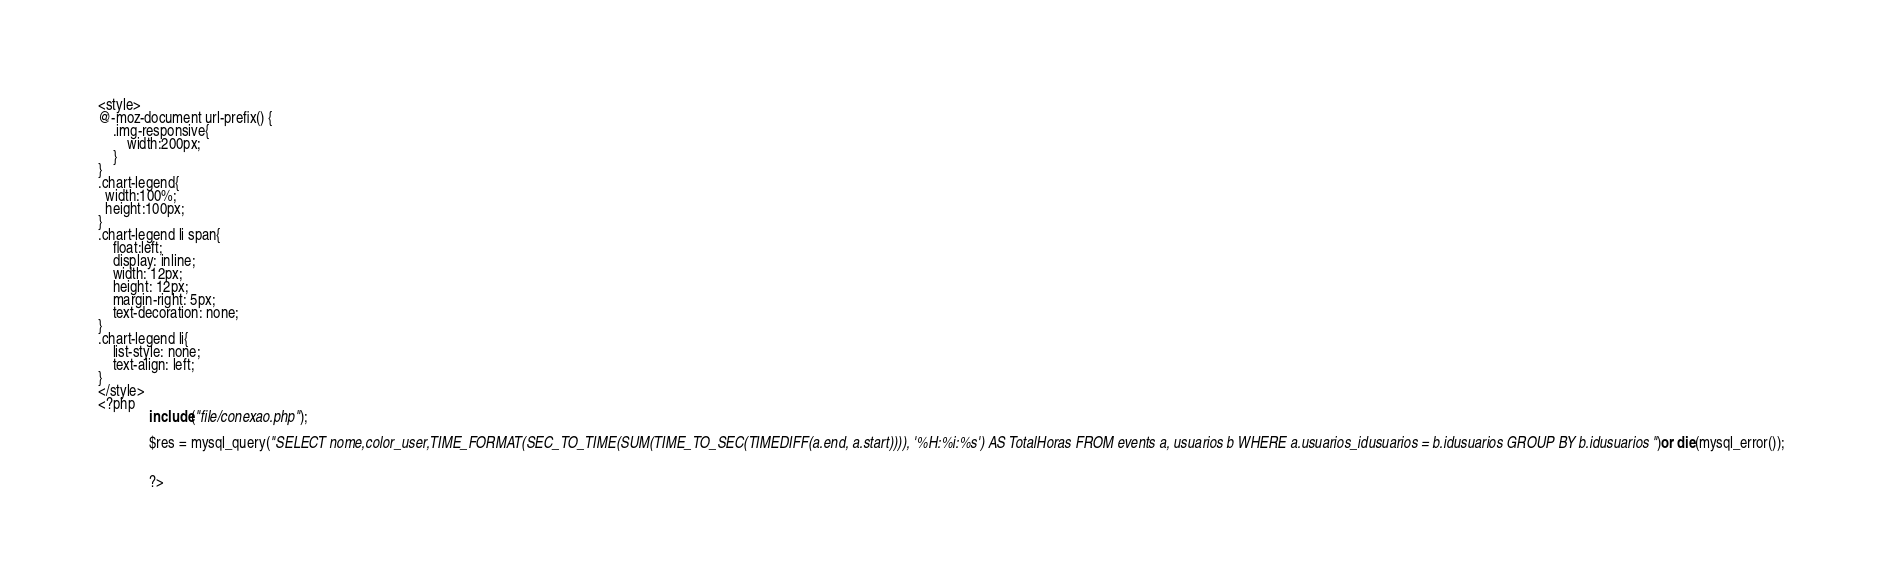Convert code to text. <code><loc_0><loc_0><loc_500><loc_500><_PHP_><style>
@-moz-document url-prefix() {
    .img-responsive{
        width:200px;
    }
}
.chart-legend{
  width:100%;
  height:100px;
}
.chart-legend li span{
    float:left;
    display: inline;
    width: 12px;
    height: 12px;
    margin-right: 5px;
    text-decoration: none;
}
.chart-legend li{
    list-style: none;
    text-align: left;
}
</style>
<?php
              include("file/conexao.php");

              $res = mysql_query("SELECT nome,color_user,TIME_FORMAT(SEC_TO_TIME(SUM(TIME_TO_SEC(TIMEDIFF(a.end, a.start)))), '%H:%i:%s') AS TotalHoras FROM events a, usuarios b WHERE a.usuarios_idusuarios = b.idusuarios GROUP BY b.idusuarios")or die(mysql_error());
              
             
              ?></code> 